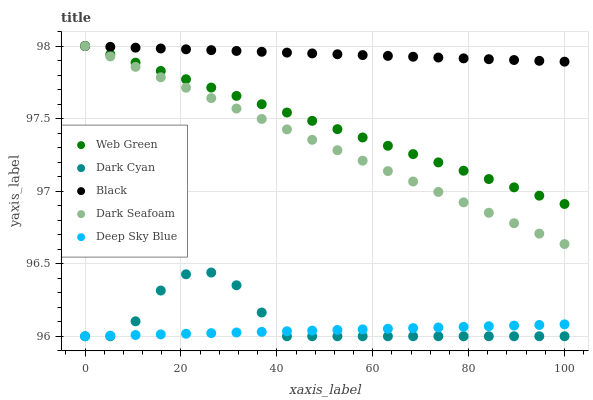Does Deep Sky Blue have the minimum area under the curve?
Answer yes or no. Yes. Does Black have the maximum area under the curve?
Answer yes or no. Yes. Does Dark Seafoam have the minimum area under the curve?
Answer yes or no. No. Does Dark Seafoam have the maximum area under the curve?
Answer yes or no. No. Is Web Green the smoothest?
Answer yes or no. Yes. Is Dark Cyan the roughest?
Answer yes or no. Yes. Is Dark Seafoam the smoothest?
Answer yes or no. No. Is Dark Seafoam the roughest?
Answer yes or no. No. Does Dark Cyan have the lowest value?
Answer yes or no. Yes. Does Dark Seafoam have the lowest value?
Answer yes or no. No. Does Web Green have the highest value?
Answer yes or no. Yes. Does Deep Sky Blue have the highest value?
Answer yes or no. No. Is Dark Cyan less than Dark Seafoam?
Answer yes or no. Yes. Is Black greater than Deep Sky Blue?
Answer yes or no. Yes. Does Black intersect Web Green?
Answer yes or no. Yes. Is Black less than Web Green?
Answer yes or no. No. Is Black greater than Web Green?
Answer yes or no. No. Does Dark Cyan intersect Dark Seafoam?
Answer yes or no. No. 